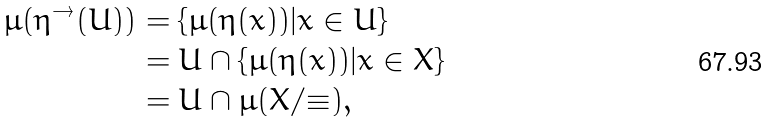<formula> <loc_0><loc_0><loc_500><loc_500>\mu ( \eta ^ { \rightarrow } ( U ) ) & = \{ \mu ( \eta ( x ) ) | x \in U \} \\ & = U \cap \{ \mu ( \eta ( x ) ) | x \in X \} \\ & = U \cap \mu ( X / { \equiv } ) ,</formula> 